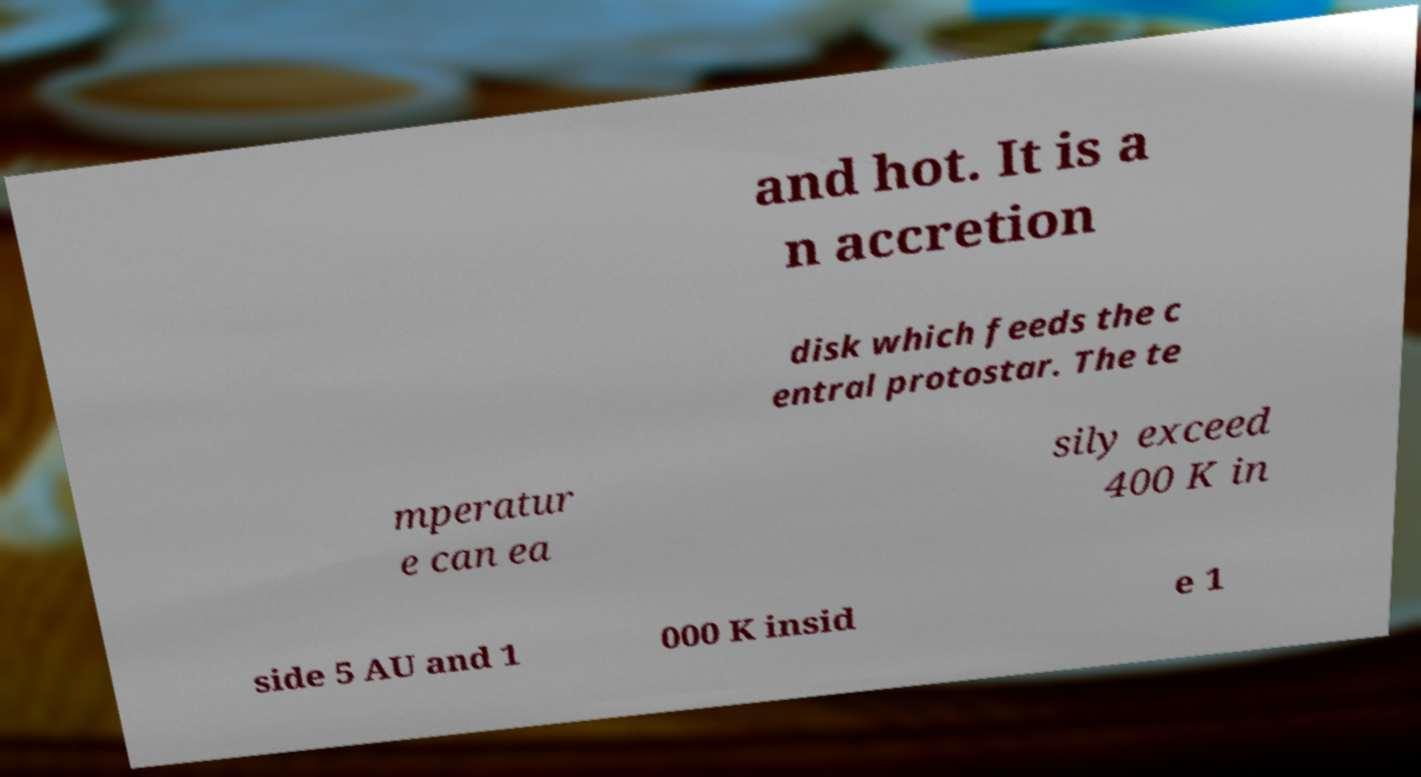Could you assist in decoding the text presented in this image and type it out clearly? and hot. It is a n accretion disk which feeds the c entral protostar. The te mperatur e can ea sily exceed 400 K in side 5 AU and 1 000 K insid e 1 